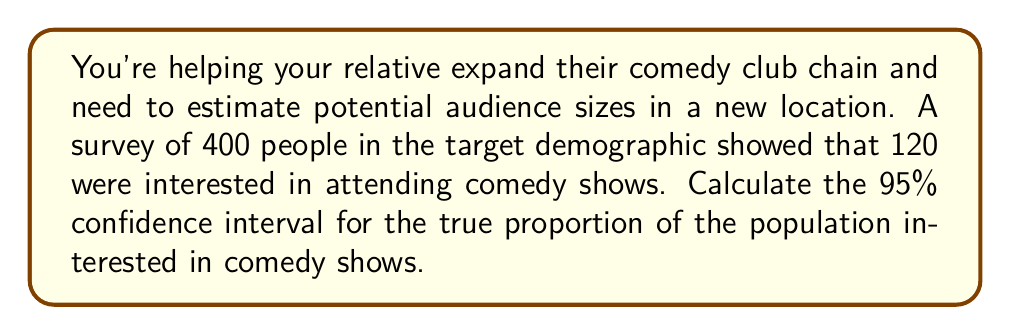Teach me how to tackle this problem. Let's approach this step-by-step:

1) First, we need to calculate the sample proportion:
   $\hat{p} = \frac{120}{400} = 0.3$

2) The formula for the confidence interval is:
   $$\hat{p} \pm z_{\alpha/2} \sqrt{\frac{\hat{p}(1-\hat{p})}{n}}$$
   Where:
   - $\hat{p}$ is the sample proportion
   - $z_{\alpha/2}$ is the critical value (1.96 for 95% confidence)
   - $n$ is the sample size

3) Let's substitute our values:
   $$0.3 \pm 1.96 \sqrt{\frac{0.3(1-0.3)}{400}}$$

4) Simplify inside the square root:
   $$0.3 \pm 1.96 \sqrt{\frac{0.3(0.7)}{400}}$$

5) Calculate:
   $$0.3 \pm 1.96 \sqrt{0.000525} = 0.3 \pm 1.96(0.0229)$$

6) Multiply:
   $$0.3 \pm 0.0449$$

7) Therefore, the confidence interval is:
   $$(0.3 - 0.0449, 0.3 + 0.0449) = (0.2551, 0.3449)$$

This means we can be 95% confident that the true proportion of the population interested in comedy shows is between 25.51% and 34.49%.
Answer: (0.2551, 0.3449) 